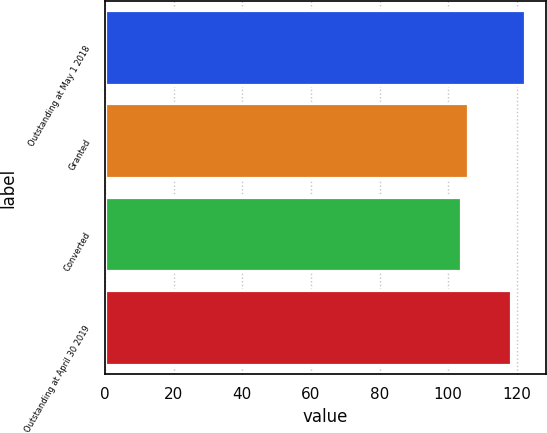<chart> <loc_0><loc_0><loc_500><loc_500><bar_chart><fcel>Outstanding at May 1 2018<fcel>Granted<fcel>Converted<fcel>Outstanding at April 30 2019<nl><fcel>122.39<fcel>105.71<fcel>103.86<fcel>118.44<nl></chart> 